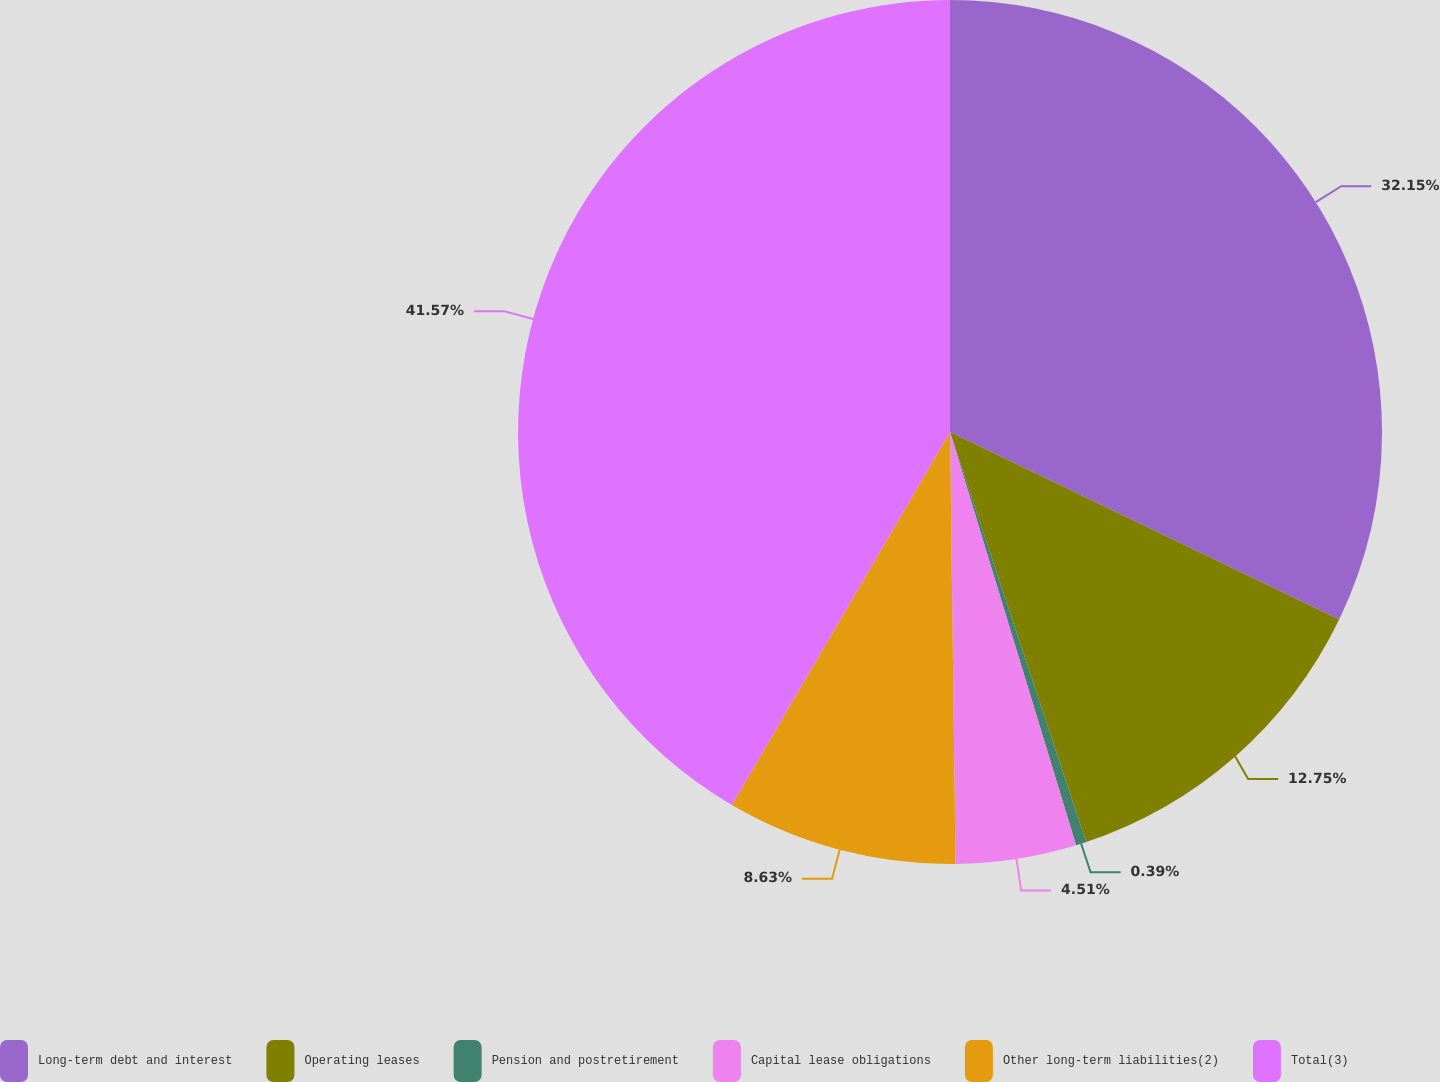Convert chart to OTSL. <chart><loc_0><loc_0><loc_500><loc_500><pie_chart><fcel>Long-term debt and interest<fcel>Operating leases<fcel>Pension and postretirement<fcel>Capital lease obligations<fcel>Other long-term liabilities(2)<fcel>Total(3)<nl><fcel>32.15%<fcel>12.75%<fcel>0.39%<fcel>4.51%<fcel>8.63%<fcel>41.58%<nl></chart> 